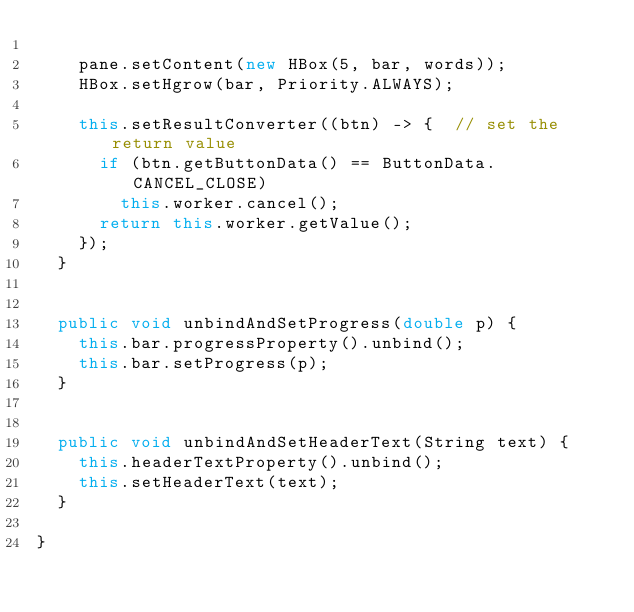Convert code to text. <code><loc_0><loc_0><loc_500><loc_500><_Java_>		
		pane.setContent(new HBox(5, bar, words));
		HBox.setHgrow(bar, Priority.ALWAYS);
		
		this.setResultConverter((btn) -> {	// set the return value
			if (btn.getButtonData() == ButtonData.CANCEL_CLOSE)
				this.worker.cancel();
			return this.worker.getValue();
		});
	}
	
	
	public void unbindAndSetProgress(double p) {
		this.bar.progressProperty().unbind();
		this.bar.setProgress(p);
	}
	
	
	public void unbindAndSetHeaderText(String text) {
		this.headerTextProperty().unbind();
		this.setHeaderText(text);
	}
	
}
</code> 